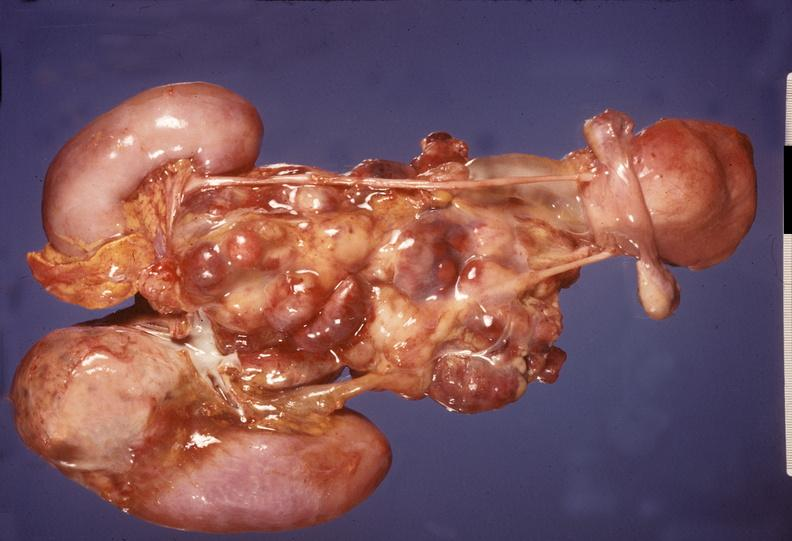does this image show adrenal, neuroblastoma?
Answer the question using a single word or phrase. Yes 